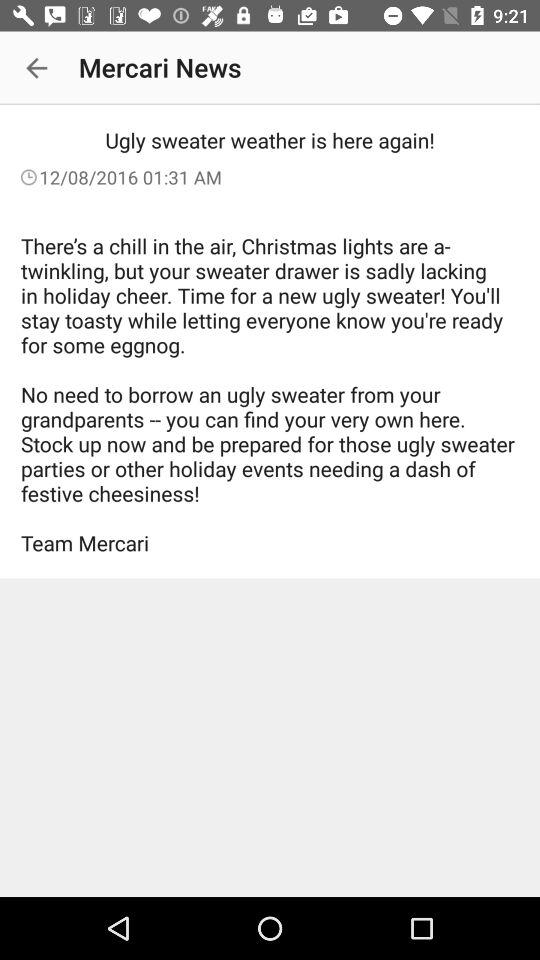What's the published date and time of the "Mercari News" article? The published date and time are December 8, 2016 and 01:31 a.m. respectively. 